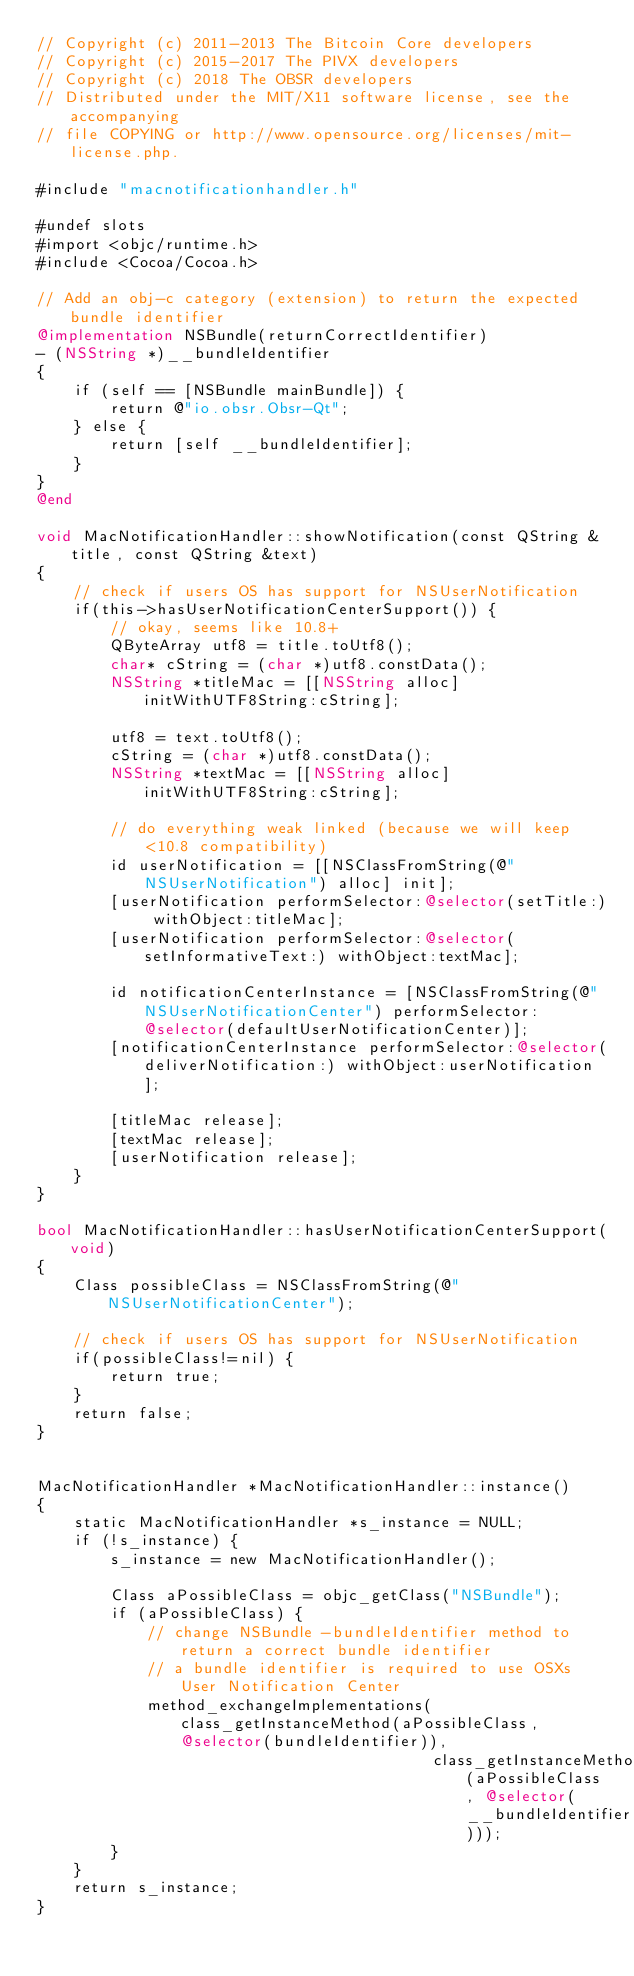<code> <loc_0><loc_0><loc_500><loc_500><_ObjectiveC_>// Copyright (c) 2011-2013 The Bitcoin Core developers
// Copyright (c) 2015-2017 The PIVX developers
// Copyright (c) 2018 The OBSR developers
// Distributed under the MIT/X11 software license, see the accompanying
// file COPYING or http://www.opensource.org/licenses/mit-license.php.

#include "macnotificationhandler.h"

#undef slots
#import <objc/runtime.h>
#include <Cocoa/Cocoa.h>

// Add an obj-c category (extension) to return the expected bundle identifier
@implementation NSBundle(returnCorrectIdentifier)
- (NSString *)__bundleIdentifier
{
    if (self == [NSBundle mainBundle]) {
        return @"io.obsr.Obsr-Qt";
    } else {
        return [self __bundleIdentifier];
    }
}
@end

void MacNotificationHandler::showNotification(const QString &title, const QString &text)
{
    // check if users OS has support for NSUserNotification
    if(this->hasUserNotificationCenterSupport()) {
        // okay, seems like 10.8+
        QByteArray utf8 = title.toUtf8();
        char* cString = (char *)utf8.constData();
        NSString *titleMac = [[NSString alloc] initWithUTF8String:cString];

        utf8 = text.toUtf8();
        cString = (char *)utf8.constData();
        NSString *textMac = [[NSString alloc] initWithUTF8String:cString];

        // do everything weak linked (because we will keep <10.8 compatibility)
        id userNotification = [[NSClassFromString(@"NSUserNotification") alloc] init];
        [userNotification performSelector:@selector(setTitle:) withObject:titleMac];
        [userNotification performSelector:@selector(setInformativeText:) withObject:textMac];

        id notificationCenterInstance = [NSClassFromString(@"NSUserNotificationCenter") performSelector:@selector(defaultUserNotificationCenter)];
        [notificationCenterInstance performSelector:@selector(deliverNotification:) withObject:userNotification];

        [titleMac release];
        [textMac release];
        [userNotification release];
    }
}

bool MacNotificationHandler::hasUserNotificationCenterSupport(void)
{
    Class possibleClass = NSClassFromString(@"NSUserNotificationCenter");

    // check if users OS has support for NSUserNotification
    if(possibleClass!=nil) {
        return true;
    }
    return false;
}


MacNotificationHandler *MacNotificationHandler::instance()
{
    static MacNotificationHandler *s_instance = NULL;
    if (!s_instance) {
        s_instance = new MacNotificationHandler();
        
        Class aPossibleClass = objc_getClass("NSBundle");
        if (aPossibleClass) {
            // change NSBundle -bundleIdentifier method to return a correct bundle identifier
            // a bundle identifier is required to use OSXs User Notification Center
            method_exchangeImplementations(class_getInstanceMethod(aPossibleClass, @selector(bundleIdentifier)),
                                           class_getInstanceMethod(aPossibleClass, @selector(__bundleIdentifier)));
        }
    }
    return s_instance;
}
</code> 